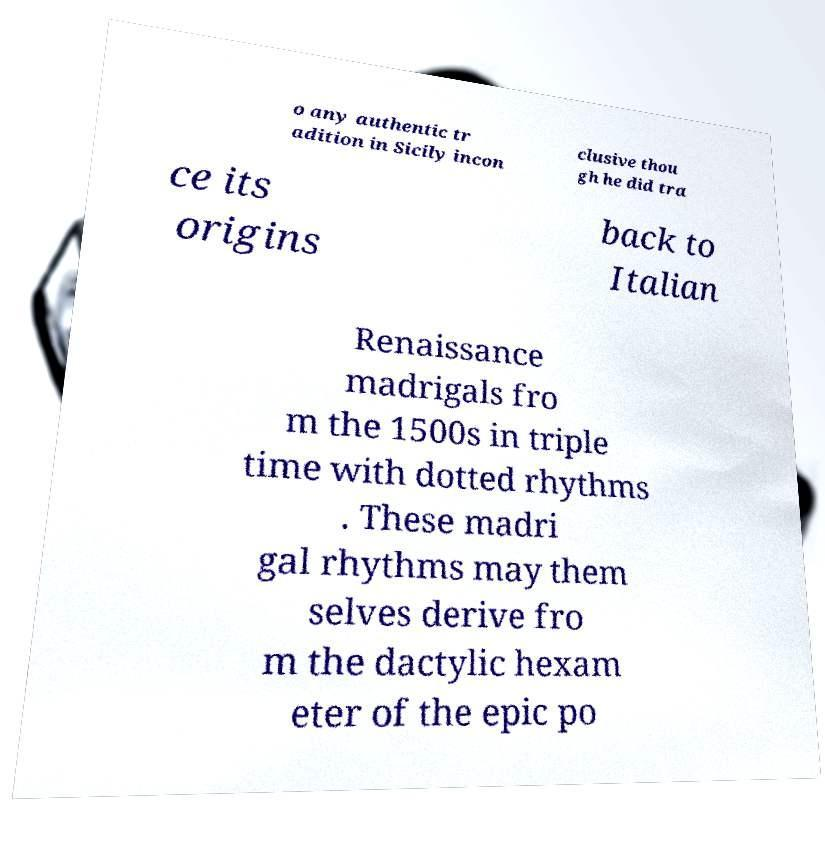Please read and relay the text visible in this image. What does it say? o any authentic tr adition in Sicily incon clusive thou gh he did tra ce its origins back to Italian Renaissance madrigals fro m the 1500s in triple time with dotted rhythms . These madri gal rhythms may them selves derive fro m the dactylic hexam eter of the epic po 